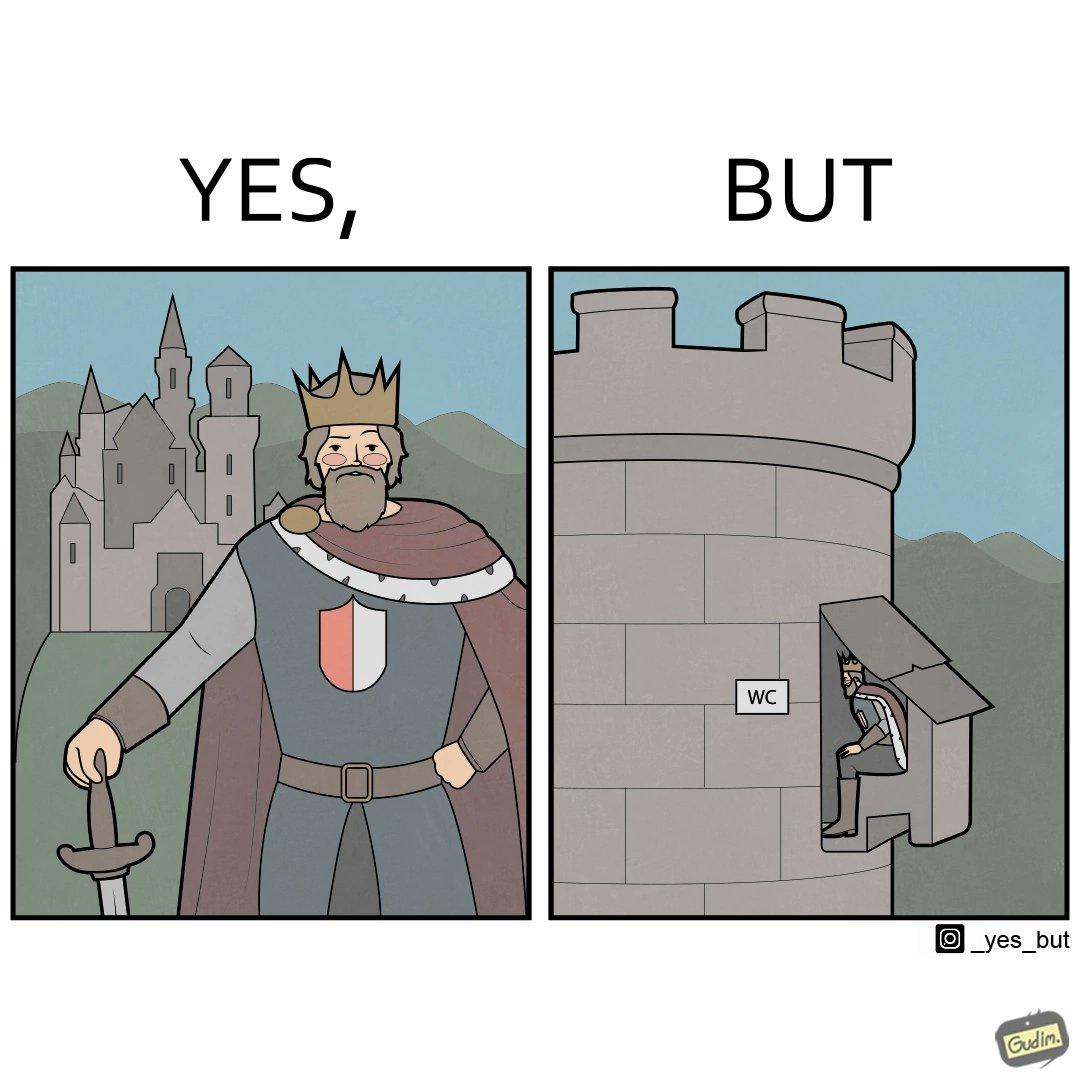Describe the contrast between the left and right parts of this image. In the left part of the image: It is a mighty king in front of a castle In the right part of the image: It is a man using the toilet in a castle 